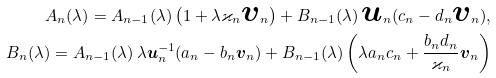<formula> <loc_0><loc_0><loc_500><loc_500>A _ { n } ( \lambda ) = A _ { n - 1 } ( \lambda ) \left ( 1 + \lambda \varkappa _ { n } { \boldsymbol v } _ { n } \right ) + B _ { n - 1 } ( \lambda ) \, { \boldsymbol u } _ { n } ( c _ { n } - d _ { n } { \boldsymbol v } _ { n } ) , \\ B _ { n } ( \lambda ) = A _ { n - 1 } ( \lambda ) \, \lambda { \boldsymbol u } _ { n } ^ { - 1 } ( a _ { n } - b _ { n } { \boldsymbol v } _ { n } ) + B _ { n - 1 } ( \lambda ) \left ( \lambda a _ { n } c _ { n } + \frac { b _ { n } d _ { n } } { \varkappa _ { n } } { \boldsymbol v } _ { n } \right )</formula> 